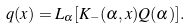Convert formula to latex. <formula><loc_0><loc_0><loc_500><loc_500>q ( x ) = L _ { \alpha } [ K _ { - } ( \alpha , x ) Q ( \alpha ) ] .</formula> 